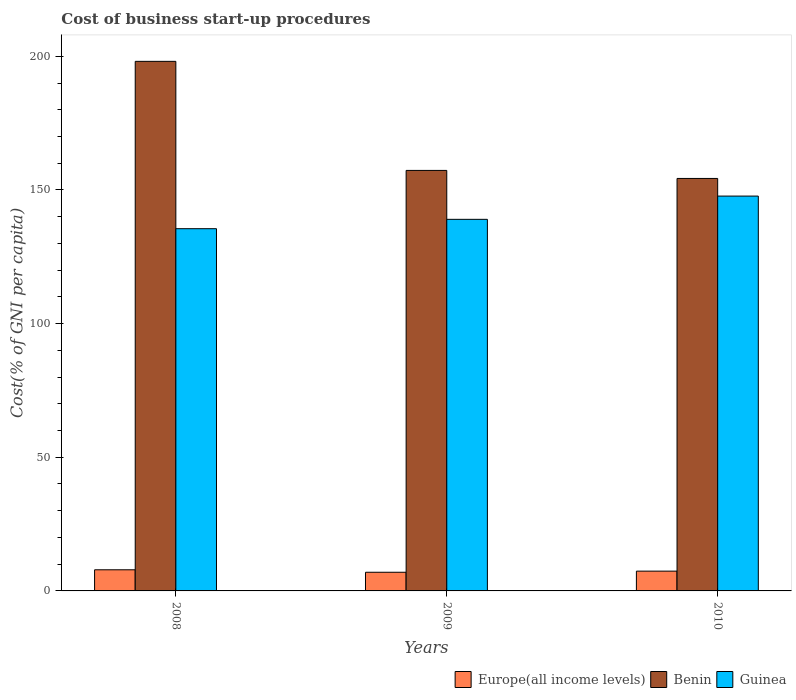How many groups of bars are there?
Offer a terse response. 3. Are the number of bars per tick equal to the number of legend labels?
Provide a succinct answer. Yes. Are the number of bars on each tick of the X-axis equal?
Provide a succinct answer. Yes. How many bars are there on the 3rd tick from the right?
Keep it short and to the point. 3. In how many cases, is the number of bars for a given year not equal to the number of legend labels?
Provide a short and direct response. 0. What is the cost of business start-up procedures in Benin in 2009?
Provide a succinct answer. 157.3. Across all years, what is the maximum cost of business start-up procedures in Benin?
Provide a short and direct response. 198.1. Across all years, what is the minimum cost of business start-up procedures in Guinea?
Give a very brief answer. 135.5. In which year was the cost of business start-up procedures in Europe(all income levels) maximum?
Provide a succinct answer. 2008. What is the total cost of business start-up procedures in Europe(all income levels) in the graph?
Make the answer very short. 22.29. What is the difference between the cost of business start-up procedures in Europe(all income levels) in 2009 and that in 2010?
Ensure brevity in your answer.  -0.42. What is the difference between the cost of business start-up procedures in Benin in 2008 and the cost of business start-up procedures in Guinea in 2010?
Your answer should be very brief. 50.4. What is the average cost of business start-up procedures in Benin per year?
Provide a succinct answer. 169.9. In the year 2008, what is the difference between the cost of business start-up procedures in Europe(all income levels) and cost of business start-up procedures in Benin?
Your response must be concise. -190.19. What is the ratio of the cost of business start-up procedures in Guinea in 2008 to that in 2010?
Offer a terse response. 0.92. Is the cost of business start-up procedures in Europe(all income levels) in 2008 less than that in 2009?
Your answer should be compact. No. What is the difference between the highest and the second highest cost of business start-up procedures in Benin?
Ensure brevity in your answer.  40.8. What is the difference between the highest and the lowest cost of business start-up procedures in Guinea?
Your response must be concise. 12.2. In how many years, is the cost of business start-up procedures in Guinea greater than the average cost of business start-up procedures in Guinea taken over all years?
Provide a short and direct response. 1. What does the 1st bar from the left in 2008 represents?
Provide a short and direct response. Europe(all income levels). What does the 3rd bar from the right in 2008 represents?
Offer a very short reply. Europe(all income levels). Is it the case that in every year, the sum of the cost of business start-up procedures in Guinea and cost of business start-up procedures in Europe(all income levels) is greater than the cost of business start-up procedures in Benin?
Offer a very short reply. No. How many bars are there?
Offer a very short reply. 9. How many years are there in the graph?
Give a very brief answer. 3. What is the difference between two consecutive major ticks on the Y-axis?
Keep it short and to the point. 50. Does the graph contain any zero values?
Make the answer very short. No. Does the graph contain grids?
Ensure brevity in your answer.  No. What is the title of the graph?
Your response must be concise. Cost of business start-up procedures. What is the label or title of the X-axis?
Your response must be concise. Years. What is the label or title of the Y-axis?
Your answer should be compact. Cost(% of GNI per capita). What is the Cost(% of GNI per capita) of Europe(all income levels) in 2008?
Offer a very short reply. 7.91. What is the Cost(% of GNI per capita) in Benin in 2008?
Make the answer very short. 198.1. What is the Cost(% of GNI per capita) in Guinea in 2008?
Your answer should be compact. 135.5. What is the Cost(% of GNI per capita) in Europe(all income levels) in 2009?
Offer a very short reply. 6.98. What is the Cost(% of GNI per capita) in Benin in 2009?
Provide a short and direct response. 157.3. What is the Cost(% of GNI per capita) in Guinea in 2009?
Keep it short and to the point. 139. What is the Cost(% of GNI per capita) of Europe(all income levels) in 2010?
Offer a terse response. 7.4. What is the Cost(% of GNI per capita) in Benin in 2010?
Your answer should be very brief. 154.3. What is the Cost(% of GNI per capita) of Guinea in 2010?
Offer a terse response. 147.7. Across all years, what is the maximum Cost(% of GNI per capita) of Europe(all income levels)?
Give a very brief answer. 7.91. Across all years, what is the maximum Cost(% of GNI per capita) of Benin?
Give a very brief answer. 198.1. Across all years, what is the maximum Cost(% of GNI per capita) in Guinea?
Provide a short and direct response. 147.7. Across all years, what is the minimum Cost(% of GNI per capita) of Europe(all income levels)?
Provide a succinct answer. 6.98. Across all years, what is the minimum Cost(% of GNI per capita) in Benin?
Your answer should be compact. 154.3. Across all years, what is the minimum Cost(% of GNI per capita) in Guinea?
Make the answer very short. 135.5. What is the total Cost(% of GNI per capita) of Europe(all income levels) in the graph?
Offer a very short reply. 22.29. What is the total Cost(% of GNI per capita) of Benin in the graph?
Provide a succinct answer. 509.7. What is the total Cost(% of GNI per capita) in Guinea in the graph?
Ensure brevity in your answer.  422.2. What is the difference between the Cost(% of GNI per capita) of Europe(all income levels) in 2008 and that in 2009?
Provide a succinct answer. 0.93. What is the difference between the Cost(% of GNI per capita) in Benin in 2008 and that in 2009?
Offer a very short reply. 40.8. What is the difference between the Cost(% of GNI per capita) in Guinea in 2008 and that in 2009?
Your answer should be very brief. -3.5. What is the difference between the Cost(% of GNI per capita) in Europe(all income levels) in 2008 and that in 2010?
Provide a succinct answer. 0.5. What is the difference between the Cost(% of GNI per capita) in Benin in 2008 and that in 2010?
Provide a short and direct response. 43.8. What is the difference between the Cost(% of GNI per capita) of Europe(all income levels) in 2009 and that in 2010?
Offer a very short reply. -0.42. What is the difference between the Cost(% of GNI per capita) in Benin in 2009 and that in 2010?
Provide a short and direct response. 3. What is the difference between the Cost(% of GNI per capita) in Europe(all income levels) in 2008 and the Cost(% of GNI per capita) in Benin in 2009?
Make the answer very short. -149.39. What is the difference between the Cost(% of GNI per capita) of Europe(all income levels) in 2008 and the Cost(% of GNI per capita) of Guinea in 2009?
Provide a succinct answer. -131.09. What is the difference between the Cost(% of GNI per capita) of Benin in 2008 and the Cost(% of GNI per capita) of Guinea in 2009?
Your answer should be very brief. 59.1. What is the difference between the Cost(% of GNI per capita) in Europe(all income levels) in 2008 and the Cost(% of GNI per capita) in Benin in 2010?
Give a very brief answer. -146.39. What is the difference between the Cost(% of GNI per capita) of Europe(all income levels) in 2008 and the Cost(% of GNI per capita) of Guinea in 2010?
Give a very brief answer. -139.79. What is the difference between the Cost(% of GNI per capita) in Benin in 2008 and the Cost(% of GNI per capita) in Guinea in 2010?
Give a very brief answer. 50.4. What is the difference between the Cost(% of GNI per capita) in Europe(all income levels) in 2009 and the Cost(% of GNI per capita) in Benin in 2010?
Ensure brevity in your answer.  -147.32. What is the difference between the Cost(% of GNI per capita) in Europe(all income levels) in 2009 and the Cost(% of GNI per capita) in Guinea in 2010?
Provide a short and direct response. -140.72. What is the average Cost(% of GNI per capita) of Europe(all income levels) per year?
Your answer should be compact. 7.43. What is the average Cost(% of GNI per capita) in Benin per year?
Offer a very short reply. 169.9. What is the average Cost(% of GNI per capita) in Guinea per year?
Keep it short and to the point. 140.73. In the year 2008, what is the difference between the Cost(% of GNI per capita) of Europe(all income levels) and Cost(% of GNI per capita) of Benin?
Provide a short and direct response. -190.19. In the year 2008, what is the difference between the Cost(% of GNI per capita) in Europe(all income levels) and Cost(% of GNI per capita) in Guinea?
Your answer should be very brief. -127.59. In the year 2008, what is the difference between the Cost(% of GNI per capita) in Benin and Cost(% of GNI per capita) in Guinea?
Your response must be concise. 62.6. In the year 2009, what is the difference between the Cost(% of GNI per capita) of Europe(all income levels) and Cost(% of GNI per capita) of Benin?
Give a very brief answer. -150.32. In the year 2009, what is the difference between the Cost(% of GNI per capita) in Europe(all income levels) and Cost(% of GNI per capita) in Guinea?
Ensure brevity in your answer.  -132.02. In the year 2010, what is the difference between the Cost(% of GNI per capita) of Europe(all income levels) and Cost(% of GNI per capita) of Benin?
Offer a very short reply. -146.9. In the year 2010, what is the difference between the Cost(% of GNI per capita) in Europe(all income levels) and Cost(% of GNI per capita) in Guinea?
Your answer should be compact. -140.3. In the year 2010, what is the difference between the Cost(% of GNI per capita) in Benin and Cost(% of GNI per capita) in Guinea?
Your answer should be compact. 6.6. What is the ratio of the Cost(% of GNI per capita) of Europe(all income levels) in 2008 to that in 2009?
Keep it short and to the point. 1.13. What is the ratio of the Cost(% of GNI per capita) in Benin in 2008 to that in 2009?
Your response must be concise. 1.26. What is the ratio of the Cost(% of GNI per capita) in Guinea in 2008 to that in 2009?
Ensure brevity in your answer.  0.97. What is the ratio of the Cost(% of GNI per capita) in Europe(all income levels) in 2008 to that in 2010?
Your response must be concise. 1.07. What is the ratio of the Cost(% of GNI per capita) in Benin in 2008 to that in 2010?
Keep it short and to the point. 1.28. What is the ratio of the Cost(% of GNI per capita) in Guinea in 2008 to that in 2010?
Offer a terse response. 0.92. What is the ratio of the Cost(% of GNI per capita) of Europe(all income levels) in 2009 to that in 2010?
Offer a terse response. 0.94. What is the ratio of the Cost(% of GNI per capita) of Benin in 2009 to that in 2010?
Your answer should be very brief. 1.02. What is the ratio of the Cost(% of GNI per capita) of Guinea in 2009 to that in 2010?
Provide a succinct answer. 0.94. What is the difference between the highest and the second highest Cost(% of GNI per capita) in Europe(all income levels)?
Give a very brief answer. 0.5. What is the difference between the highest and the second highest Cost(% of GNI per capita) in Benin?
Your answer should be very brief. 40.8. What is the difference between the highest and the second highest Cost(% of GNI per capita) of Guinea?
Keep it short and to the point. 8.7. What is the difference between the highest and the lowest Cost(% of GNI per capita) of Europe(all income levels)?
Your answer should be very brief. 0.93. What is the difference between the highest and the lowest Cost(% of GNI per capita) in Benin?
Make the answer very short. 43.8. What is the difference between the highest and the lowest Cost(% of GNI per capita) in Guinea?
Your answer should be very brief. 12.2. 